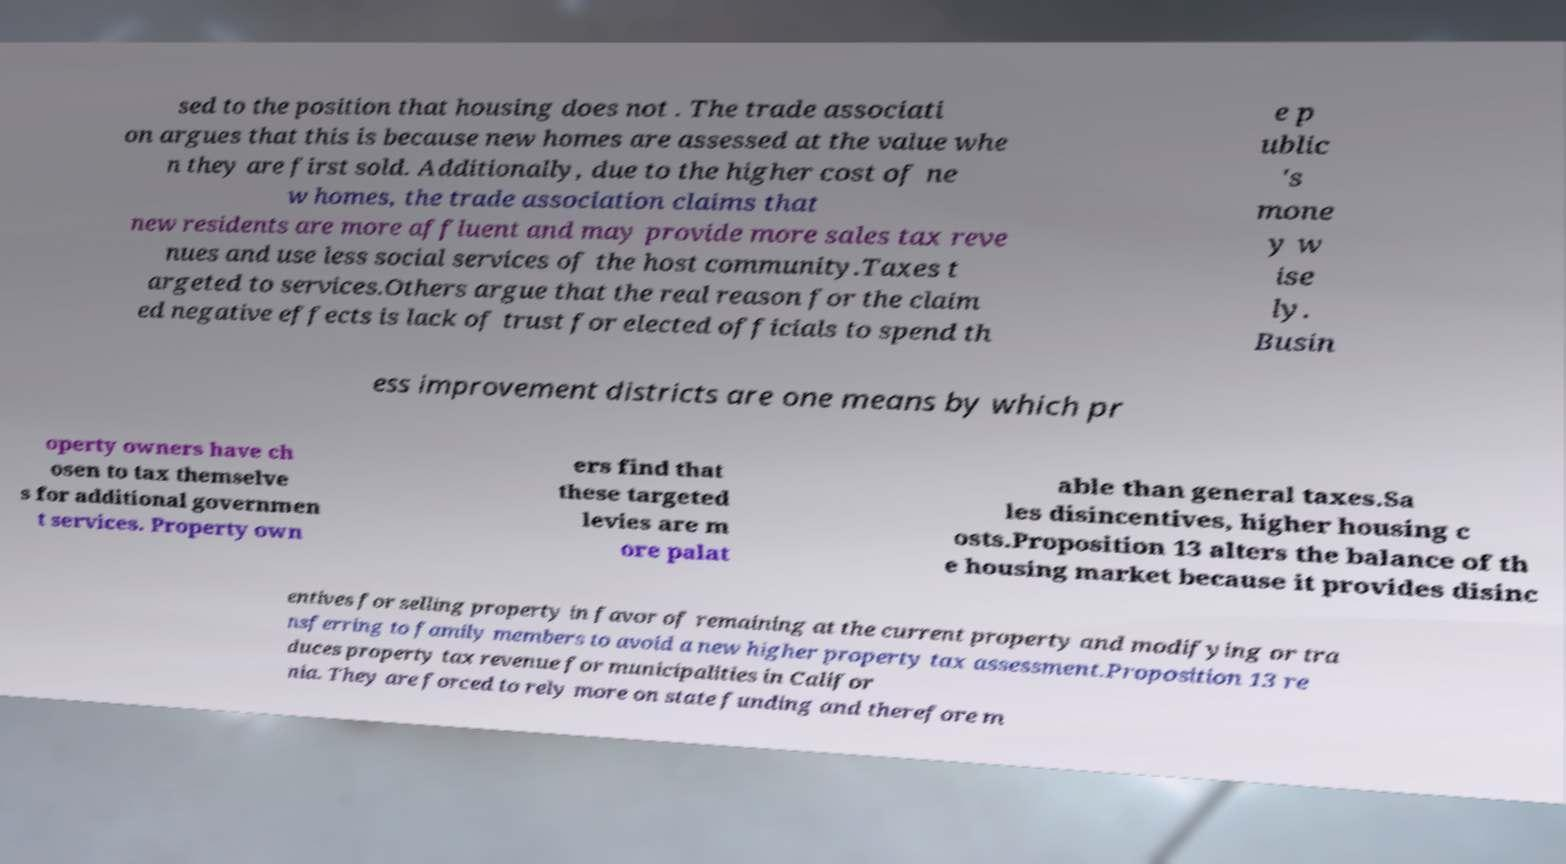Can you accurately transcribe the text from the provided image for me? sed to the position that housing does not . The trade associati on argues that this is because new homes are assessed at the value whe n they are first sold. Additionally, due to the higher cost of ne w homes, the trade association claims that new residents are more affluent and may provide more sales tax reve nues and use less social services of the host community.Taxes t argeted to services.Others argue that the real reason for the claim ed negative effects is lack of trust for elected officials to spend th e p ublic 's mone y w ise ly. Busin ess improvement districts are one means by which pr operty owners have ch osen to tax themselve s for additional governmen t services. Property own ers find that these targeted levies are m ore palat able than general taxes.Sa les disincentives, higher housing c osts.Proposition 13 alters the balance of th e housing market because it provides disinc entives for selling property in favor of remaining at the current property and modifying or tra nsferring to family members to avoid a new higher property tax assessment.Proposition 13 re duces property tax revenue for municipalities in Califor nia. They are forced to rely more on state funding and therefore m 